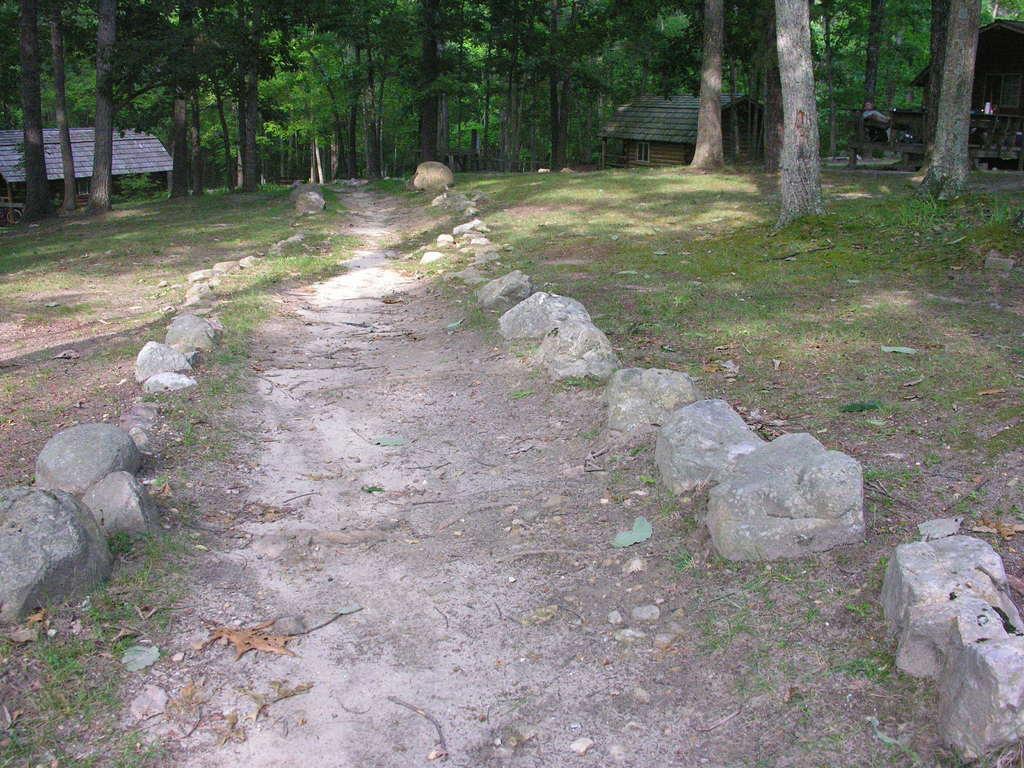In one or two sentences, can you explain what this image depicts? In the picture I can see the grass and rocks on the ground. In the background I can see houses, trees and some other objects. 